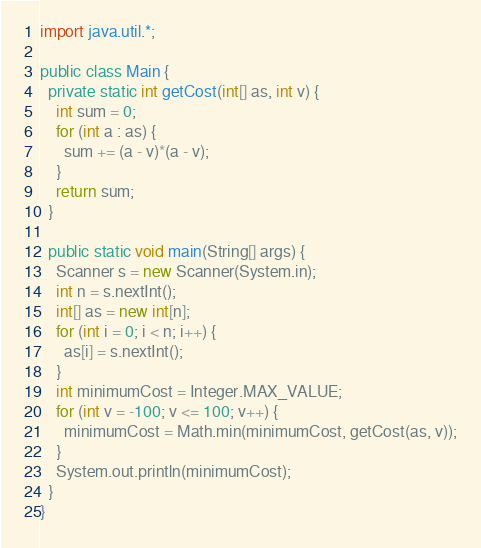<code> <loc_0><loc_0><loc_500><loc_500><_Java_>import java.util.*;

public class Main {
  private static int getCost(int[] as, int v) {
    int sum = 0;
    for (int a : as) {
      sum += (a - v)*(a - v);
    }
    return sum;
  }

  public static void main(String[] args) {
    Scanner s = new Scanner(System.in);
    int n = s.nextInt();
    int[] as = new int[n];
    for (int i = 0; i < n; i++) {
      as[i] = s.nextInt();
    }
    int minimumCost = Integer.MAX_VALUE;
    for (int v = -100; v <= 100; v++) {
      minimumCost = Math.min(minimumCost, getCost(as, v));
    }
    System.out.println(minimumCost);
  }
}
</code> 